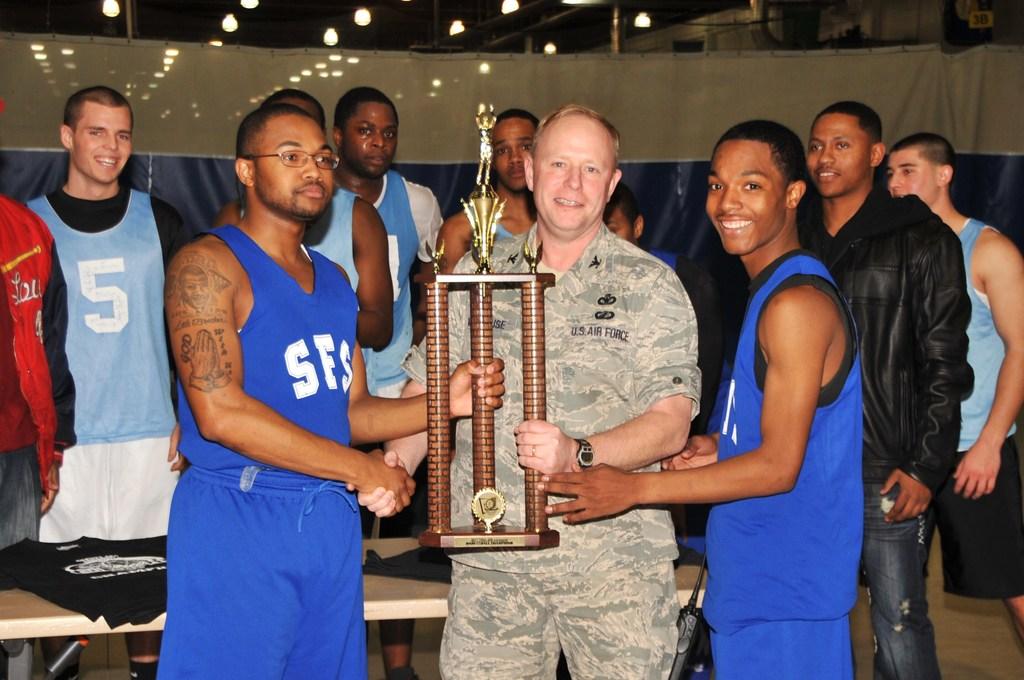What number is on the light blue jersey in the back?
Your answer should be very brief. 5. What division of the army is the man in the middle?
Your answer should be very brief. Air force. 